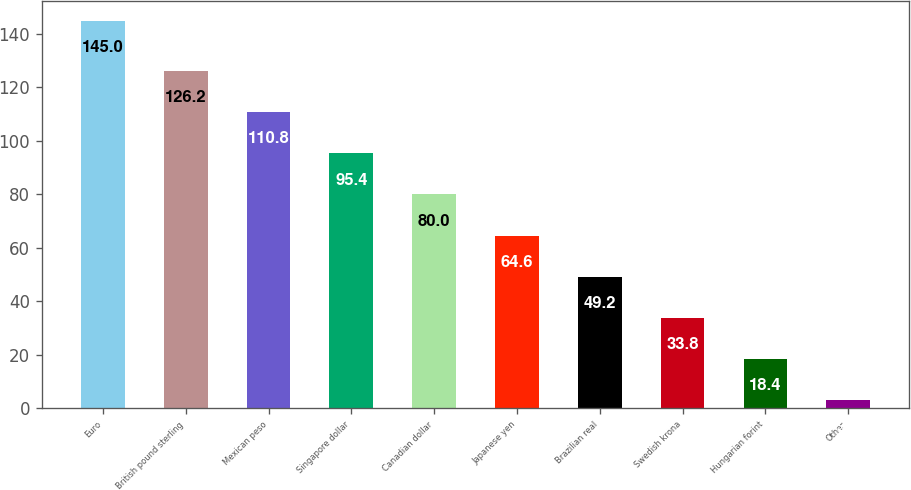Convert chart. <chart><loc_0><loc_0><loc_500><loc_500><bar_chart><fcel>Euro<fcel>British pound sterling<fcel>Mexican peso<fcel>Singapore dollar<fcel>Canadian dollar<fcel>Japanese yen<fcel>Brazilian real<fcel>Swedish krona<fcel>Hungarian forint<fcel>Other<nl><fcel>145<fcel>126.2<fcel>110.8<fcel>95.4<fcel>80<fcel>64.6<fcel>49.2<fcel>33.8<fcel>18.4<fcel>3<nl></chart> 